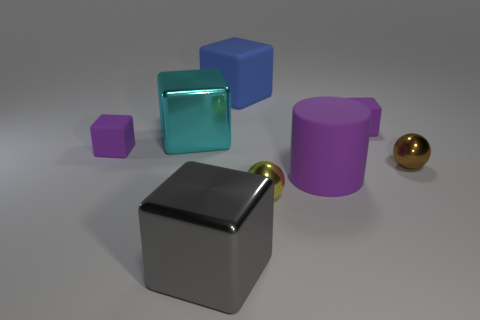Are there any matte cylinders that have the same size as the yellow ball? No, there are not any matte cylinders that are of the same size as the yellow ball. The cylinders shown have different dimensions and the closest cylinder in terms of size has a purple color and a glossy surface finish. 